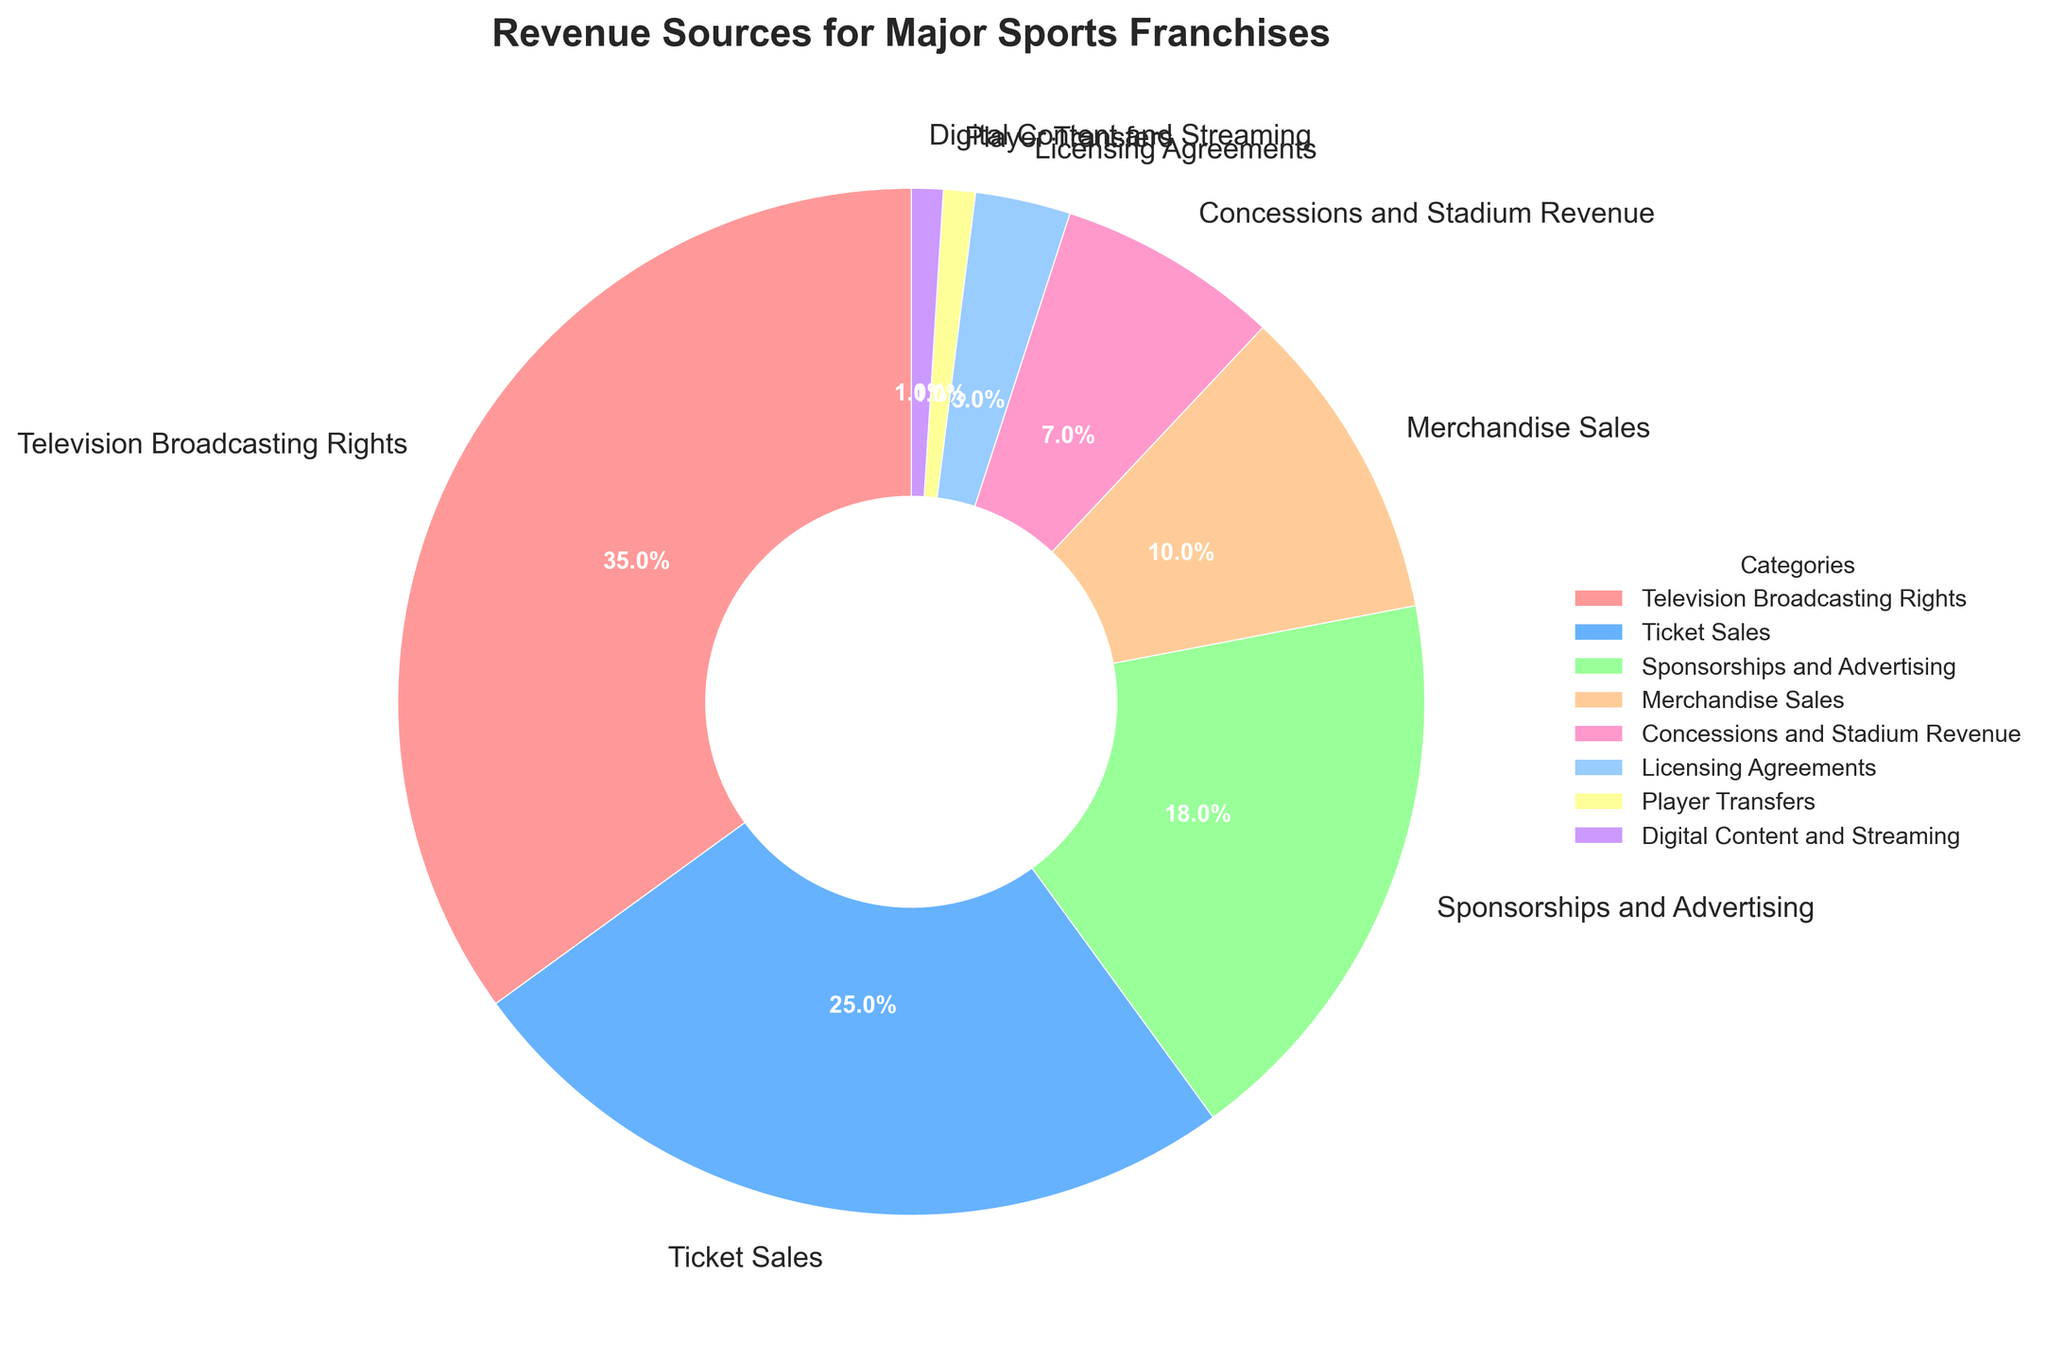What is the largest revenue source for major sports franchises? The largest segment in the pie chart, represented by the biggest wedge, signifies the major revenue source. The label indicates "Television Broadcasting Rights" occupying 35%.
Answer: Television Broadcasting Rights How much more revenue do Ticket Sales generate compared to Sponsorships and Advertising? Identify the percentages for Ticket Sales (25%) and Sponsorships and Advertising (18%). Subtract the smaller percentage from the larger one: 25% - 18% = 7%.
Answer: 7% Which revenue source contributes the least to the overall revenue for major sports franchises? The smallest wedge and its label indicate the least contributive revenue source, marked at 1%. It shows categories "Player Transfers" and "Digital Content and Streaming" both at 1%.
Answer: Player Transfers, Digital Content and Streaming What's the combined percentage of revenue from Merchandise Sales and Concessions and Stadium Revenue? Locate the percentages for Merchandise Sales (10%) and Concessions and Stadium Revenue (7%). Sum them up: 10% + 7% = 17%.
Answer: 17% How many categories contribute less than 10% each to the overall revenue? Identify wedges with labels less than 10%: Concessions and Stadium Revenue (7%), Licensing Agreements (3%), Player Transfers (1%), and Digital Content and Streaming (1%). Total count: 4 categories.
Answer: 4 What is the combined revenue percentage of categories contributing 25% or more? Identify the categories and their percentages: Television Broadcasting Rights (35%) and Ticket Sales (25%). Sum them: 35% + 25% = 60%.
Answer: 60% Are revenue sources from Television Broadcasting Rights greater than the combination of Sponsorships and Advertising and Merchandise Sales? Calculate Sponsorships and Advertising (18%) plus Merchandise Sales (10%): 18% + 10% = 28%. Compare this to Television Broadcasting Rights (35%), which is greater.
Answer: Yes Which categories have the same revenue percentage? Identify categories and their associated percentages and find matching values: Player Transfers and Digital Content and Streaming both at 1%.
Answer: Player Transfers, Digital Content and Streaming How does the combined revenue from Licensing Agreements and Player Transfers compare to Concessions and Stadium Revenue? Find the sum of Licensing Agreements (3%) and Player Transfers (1%): 3% + 1% = 4%. Compare to Concessions and Stadium Revenue (7%), lesser.
Answer: Less 